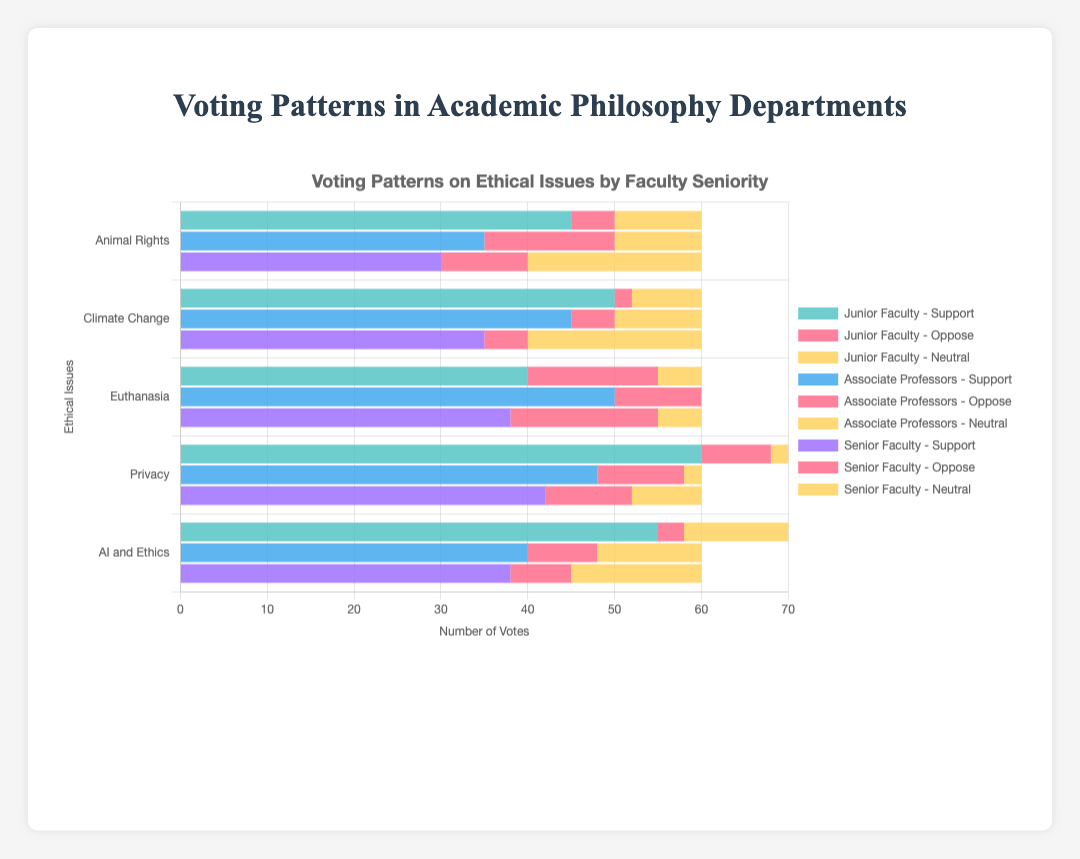What is the total number of Junior Faculty who support Animal Rights and Climate Change? To find the total, sum the number of Junior Faculty who support Animal Rights (45) and Climate Change (50). 45 + 50 = 95
Answer: 95 Which faculty group has the highest support for AI and Ethics? Compare the support values for AI and Ethics across Junior Faculty (55), Associate Professors (40), and Senior Faculty (38). The group with the highest value is Junior Faculty with 55 votes.
Answer: Junior Faculty What is the difference in the number of neutral votes on Euthanasia between Junior Faculty and Associate Professors? Determine the neutral votes on Euthanasia, which are 5 for Junior Faculty and 0 for Associate Professors. Calculate the difference: 5 - 0 = 5
Answer: 5 How do the opposition votes on Privacy compare across all three faculty groups? Look at the opposition votes for Privacy: Junior Faculty (8), Associate Professors (10), and Senior Faculty (10). Compare the values where 8 < 10 = 10, indicating Junior Faculty have fewer opposition votes than both Associate Professors and Senior Faculty, who have equal opposition votes.
Answer: Junior Faculty < Associate Professors = Senior Faculty What is the sum of neutral votes on AI and Ethics across all faculty groups? Add the neutral votes for AI and Ethics from Junior Faculty (12), Associate Professors (12), and Senior Faculty (15). 12 + 12 + 15 = 39
Answer: 39 